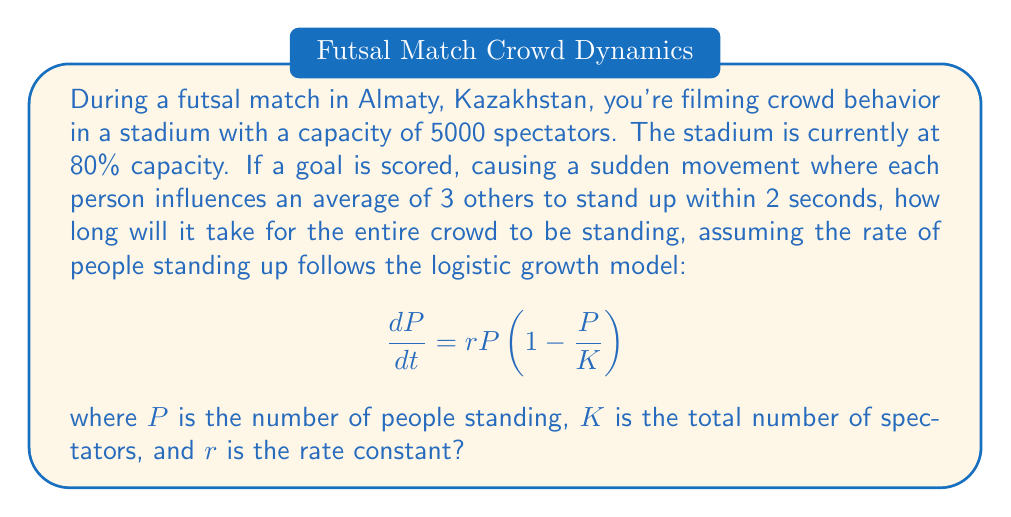Solve this math problem. Let's approach this step-by-step:

1) First, we need to calculate the total number of spectators (K):
   $K = 5000 \times 0.80 = 4000$ spectators

2) We're given that each person influences 3 others within 2 seconds. This means that in 2 seconds, the number of people standing quadruples. We can use this to find r:
   
   $P(2) = 4P(0)$
   
   In the logistic model, for small t and P << K, we can approximate:
   $P(t) \approx P(0)e^{rt}$
   
   So, $4 = e^{2r}$
   $\ln(4) = 2r$
   $r = \frac{\ln(4)}{2} \approx 0.693$ per second

3) Now we have our complete logistic equation:
   $$\frac{dP}{dt} = 0.693P(1-\frac{P}{4000})$$

4) To find the time when everyone is standing, we need to solve for t when P is very close to K (let's say 99.9% of K):
   
   $\frac{4000}{1+Ce^{-0.693t}} = 3996$

   Where C is a constant determined by the initial conditions.

5) Solving for t:
   $1+Ce^{-0.693t} = \frac{4000}{3996} \approx 1.001$
   $Ce^{-0.693t} = 0.001$
   $-0.693t = \ln(\frac{0.001}{C})$
   $t = \frac{\ln(C) - \ln(0.001)}{0.693}$

6) To find C, we use the initial condition. Let's assume 10 people initially stand up:
   $10 = \frac{4000}{1+C}$
   $C = 399$

7) Now we can solve for t:
   $t = \frac{\ln(399) - \ln(0.001)}{0.693} \approx 13.3$ seconds
Answer: 13.3 seconds 